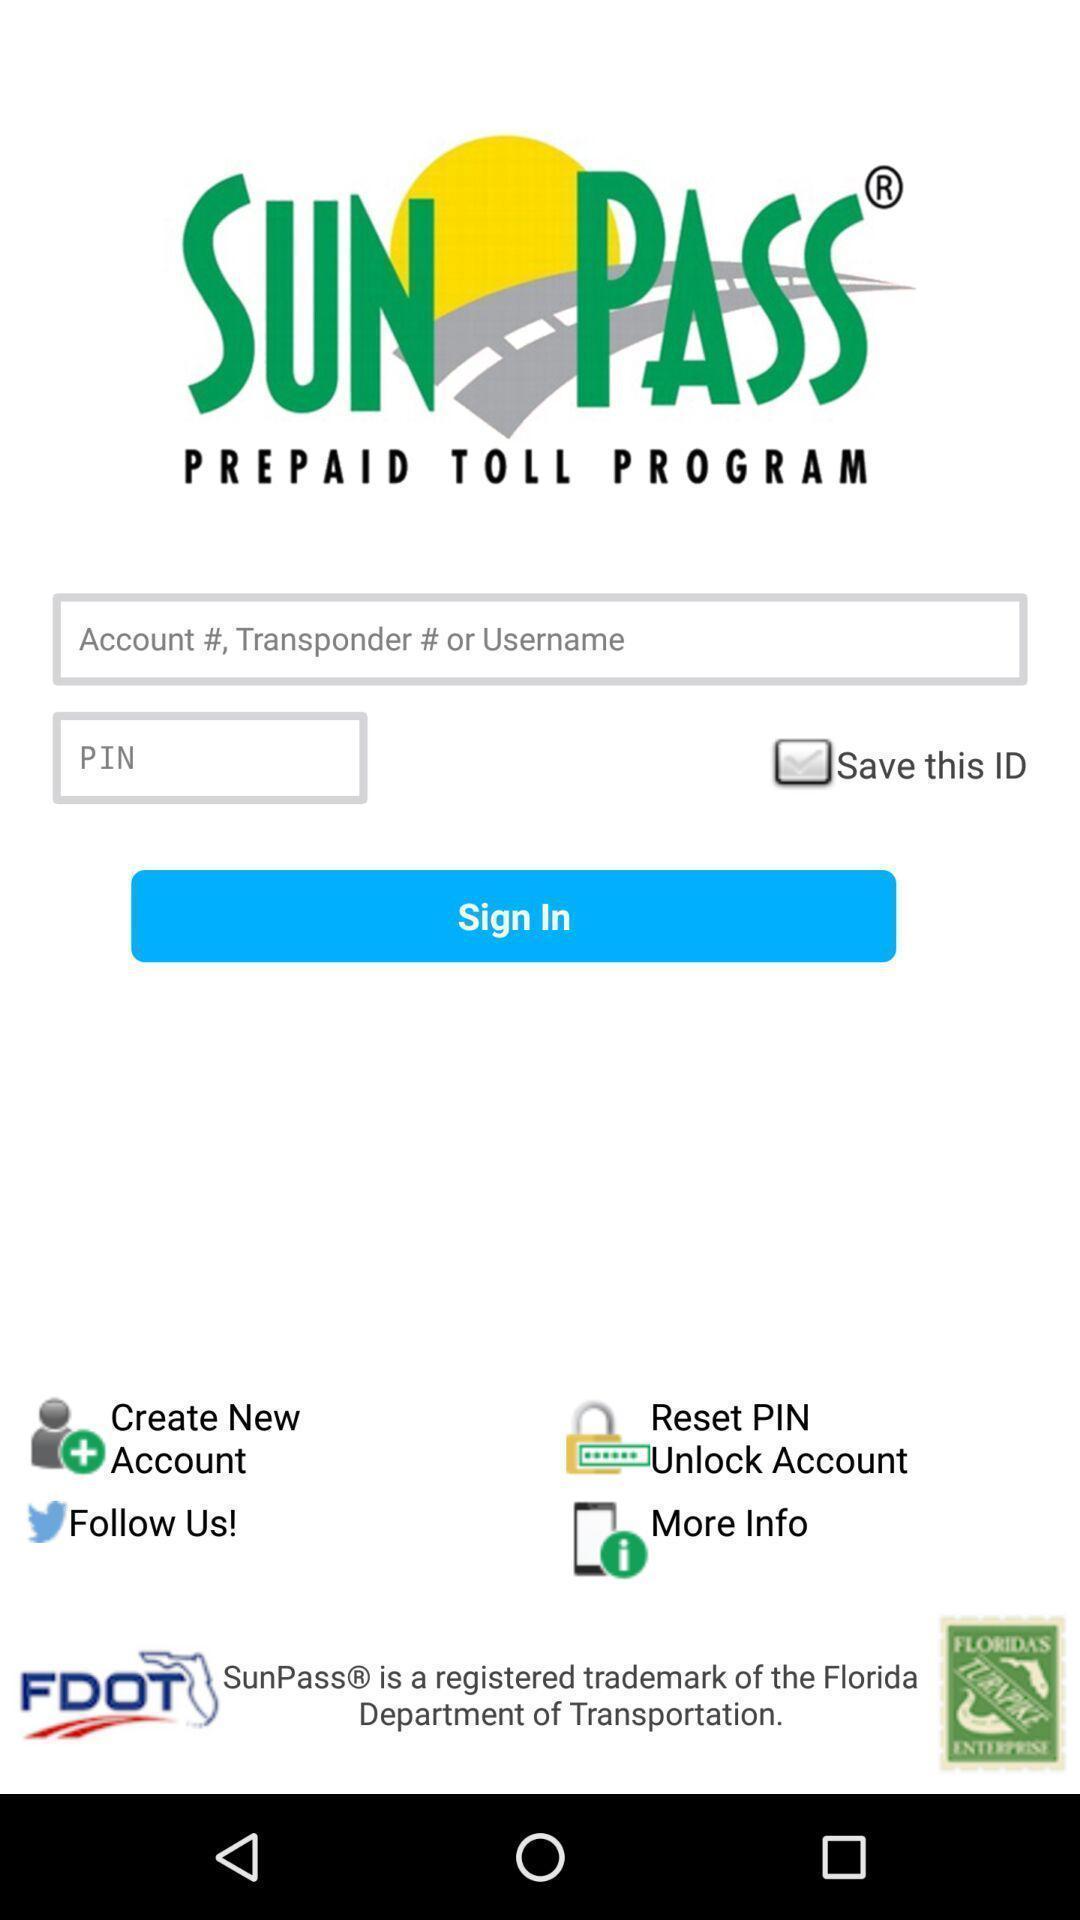Provide a textual representation of this image. Sign in page of a social app. 